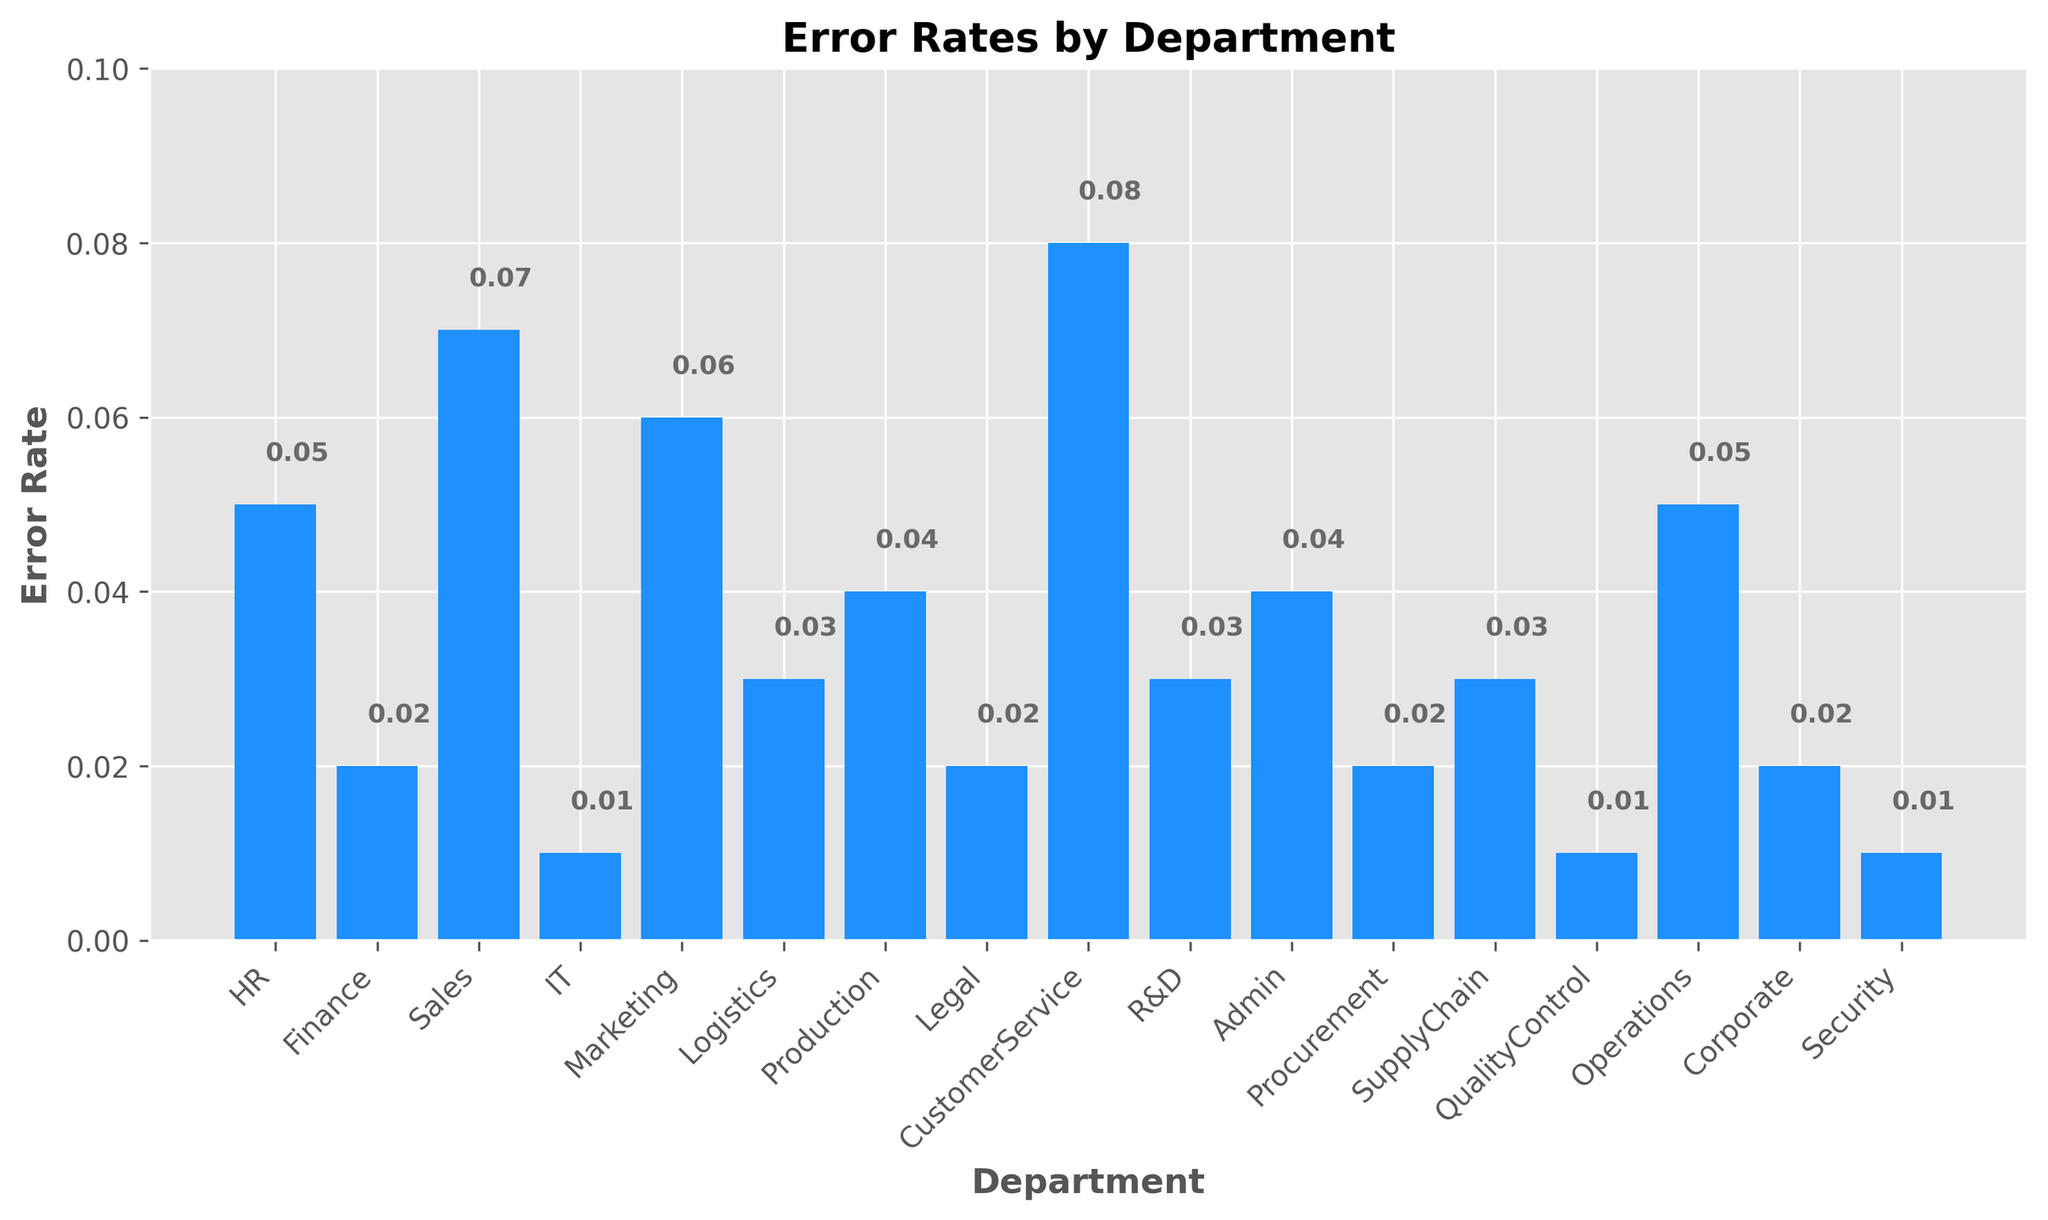What's the highest error rate among the departments? Look at the height of the bars representing the error rates for each department. The tallest bar indicates the highest error rate. The CustomerService department has the highest bar.
Answer: CustomerService What's the difference in error rates between the HR and IT departments? The error rate for the HR department is 0.05, and for the IT department, it is 0.01. Subtract the IT error rate from the HR error rate: 0.05 - 0.01.
Answer: 0.04 Which departments have an error rate of 0.02? Identify the bars that reach the 0.02 mark on the y-axis. The bars for Finance, Legal, Procurement, and Corporate are at this level.
Answer: Finance, Legal, Procurement, Corporate What’s the average error rate of the departments with rates below 0.03? The departments with error rates below 0.03 are Finance, IT, Legal, Procurement, QualityControl, and Security. Add their error rates: 0.02 + 0.01 + 0.02 + 0.02 + 0.01 + 0.01 = 0.09. Divide by the number of departments: 0.09 / 6.
Answer: 0.015 How much higher is the error rate for Sales compared to Logistics? The error rate for Sales is 0.07, and for Logistics, it is 0.03. Subtract the Logistics rate from the Sales rate: 0.07 - 0.03.
Answer: 0.04 Which department has an error rate that exactly matches the midpoint between the highest and lowest error rates? The highest error rate is 0.08 (CustomerService) and the lowest is 0.01 (IT, QualityControl, Security). The midpoint is (0.08 + 0.01) / 2 = 0.045. The closest department to this value is Admin and Production, each at 0.04.
Answer: Admin, Production What’s the sum of error rates for the departments with the three lowest rates? The three lowest error rates are from IT (0.01), QualityControl (0.01), and Security (0.01). Add their rates: 0.01 + 0.01 + 0.01 = 0.03.
Answer: 0.03 Which department's error rate is closest to the organization-wide average error rate? First, calculate the average error rate of all departments:
Sum = 0.05 + 0.02 + 0.07 + 0.01 + 0.06 + 0.03 + 0.04 + 0.02 + 0.08 + 0.03 + 0.04 + 0.02 + 0.03 + 0.01 + 0.05 + 0.02 + 0.01 = 0.55. The number of departments is 17. The average is 0.55 / 17 = 0.032. The closest is Logistics, SupplyChain, or R&D, each at 0.03.
Answer: Logistics, SupplyChain, R&D 